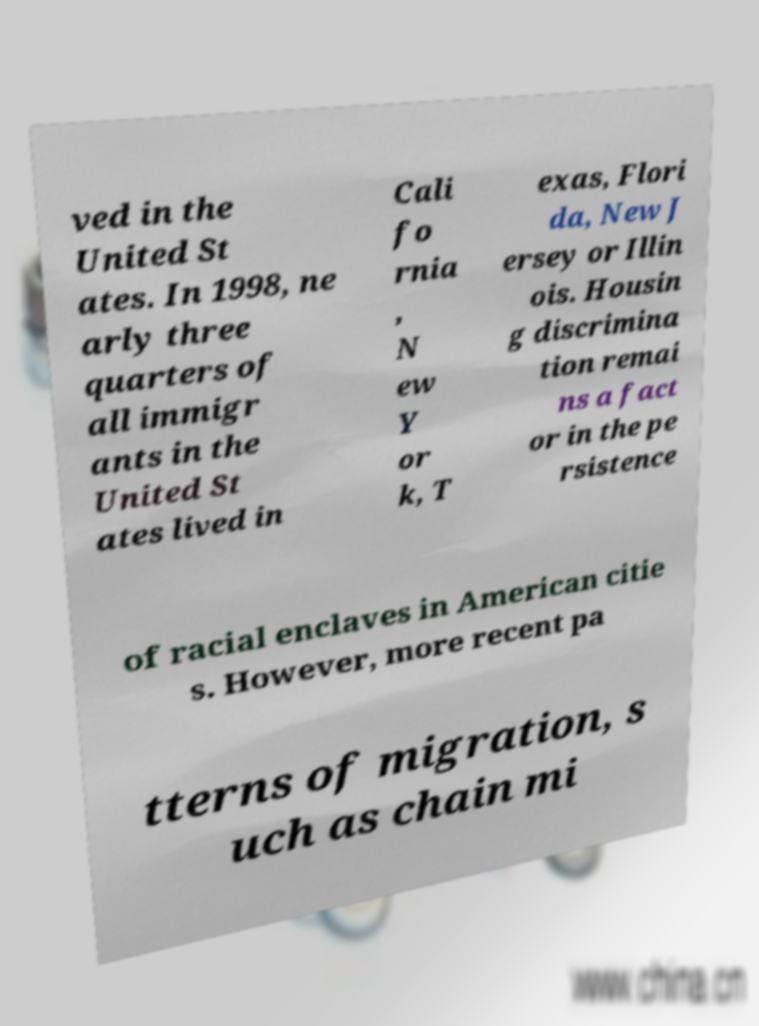Please read and relay the text visible in this image. What does it say? ved in the United St ates. In 1998, ne arly three quarters of all immigr ants in the United St ates lived in Cali fo rnia , N ew Y or k, T exas, Flori da, New J ersey or Illin ois. Housin g discrimina tion remai ns a fact or in the pe rsistence of racial enclaves in American citie s. However, more recent pa tterns of migration, s uch as chain mi 